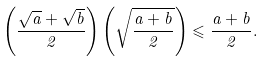<formula> <loc_0><loc_0><loc_500><loc_500>\left ( { \frac { \sqrt { a } + \sqrt { b } } { 2 } } \right ) \left ( { \sqrt { \frac { a + b } { 2 } } } \right ) \leqslant \frac { a + b } { 2 } .</formula> 